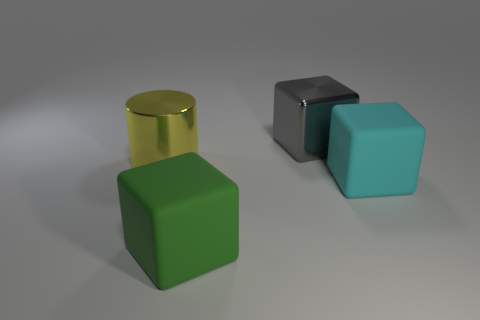Are there more rubber objects in front of the large cyan matte cube than red shiny cubes?
Keep it short and to the point. Yes. There is another large thing that is made of the same material as the large green thing; what shape is it?
Offer a terse response. Cube. There is a block behind the object to the right of the gray metallic object; what color is it?
Ensure brevity in your answer.  Gray. Is the big cyan matte object the same shape as the big yellow thing?
Offer a very short reply. No. What is the material of the big green object that is the same shape as the cyan matte object?
Provide a succinct answer. Rubber. Is there a object behind the rubber block on the right side of the shiny thing that is right of the big metal cylinder?
Provide a short and direct response. Yes. Does the gray object have the same shape as the big metallic thing in front of the gray thing?
Provide a short and direct response. No. Are any large metal cylinders visible?
Make the answer very short. Yes. Is there a green thing made of the same material as the large cyan block?
Your response must be concise. Yes. The cylinder has what color?
Give a very brief answer. Yellow. 